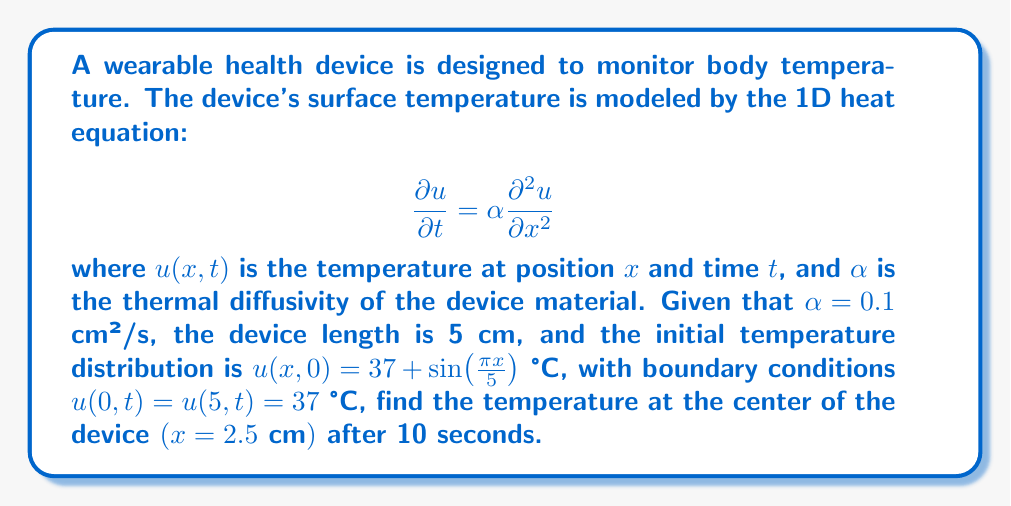Provide a solution to this math problem. To solve this problem, we'll use the separation of variables method for the heat equation:

1) Assume a solution of the form $u(x,t) = X(x)T(t)$

2) Substituting into the heat equation:
   $$X(x)T'(t) = \alpha X''(x)T(t)$$
   $$\frac{T'(t)}{T(t)} = \alpha \frac{X''(x)}{X(x)} = -\lambda$$

3) This gives us two ODEs:
   $$T'(t) + \alpha \lambda T(t) = 0$$
   $$X''(x) + \lambda X(x) = 0$$

4) Given the boundary conditions, we have $X(0) = X(5) = 0$, which leads to the eigenvalues:
   $$\lambda_n = (\frac{n\pi}{5})^2, n = 1,2,3,...$$

5) The general solution is:
   $$u(x,t) = \sum_{n=1}^{\infty} B_n \sin(\frac{n\pi x}{5}) e^{-\alpha (\frac{n\pi}{5})^2 t} + 37$$

6) To find $B_n$, we use the initial condition:
   $$37 + \sin(\frac{\pi x}{5}) = \sum_{n=1}^{\infty} B_n \sin(\frac{n\pi x}{5}) + 37$$

7) This implies $B_1 = 1$ and $B_n = 0$ for $n > 1$

8) Therefore, the solution is:
   $$u(x,t) = \sin(\frac{\pi x}{5}) e^{-\alpha (\frac{\pi}{5})^2 t} + 37$$

9) At $x = 2.5$ cm and $t = 10$ s:
   $$u(2.5,10) = \sin(\frac{\pi \cdot 2.5}{5}) e^{-0.1 (\frac{\pi}{5})^2 \cdot 10} + 37$$
   $$= 1 \cdot e^{-0.1 (\frac{\pi}{5})^2 \cdot 10} + 37$$
   $$\approx 0.5403 + 37 = 37.5403 \text{ °C}$$
Answer: 37.5403 °C 